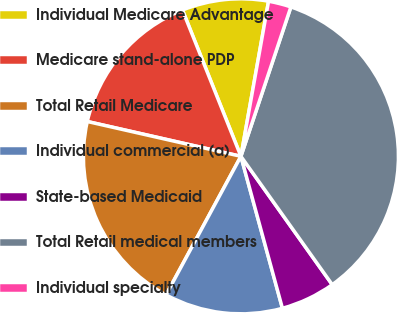<chart> <loc_0><loc_0><loc_500><loc_500><pie_chart><fcel>Individual Medicare Advantage<fcel>Medicare stand-alone PDP<fcel>Total Retail Medicare<fcel>Individual commercial (a)<fcel>State-based Medicaid<fcel>Total Retail medical members<fcel>Individual specialty<nl><fcel>8.86%<fcel>15.4%<fcel>20.66%<fcel>12.13%<fcel>5.6%<fcel>35.02%<fcel>2.33%<nl></chart> 